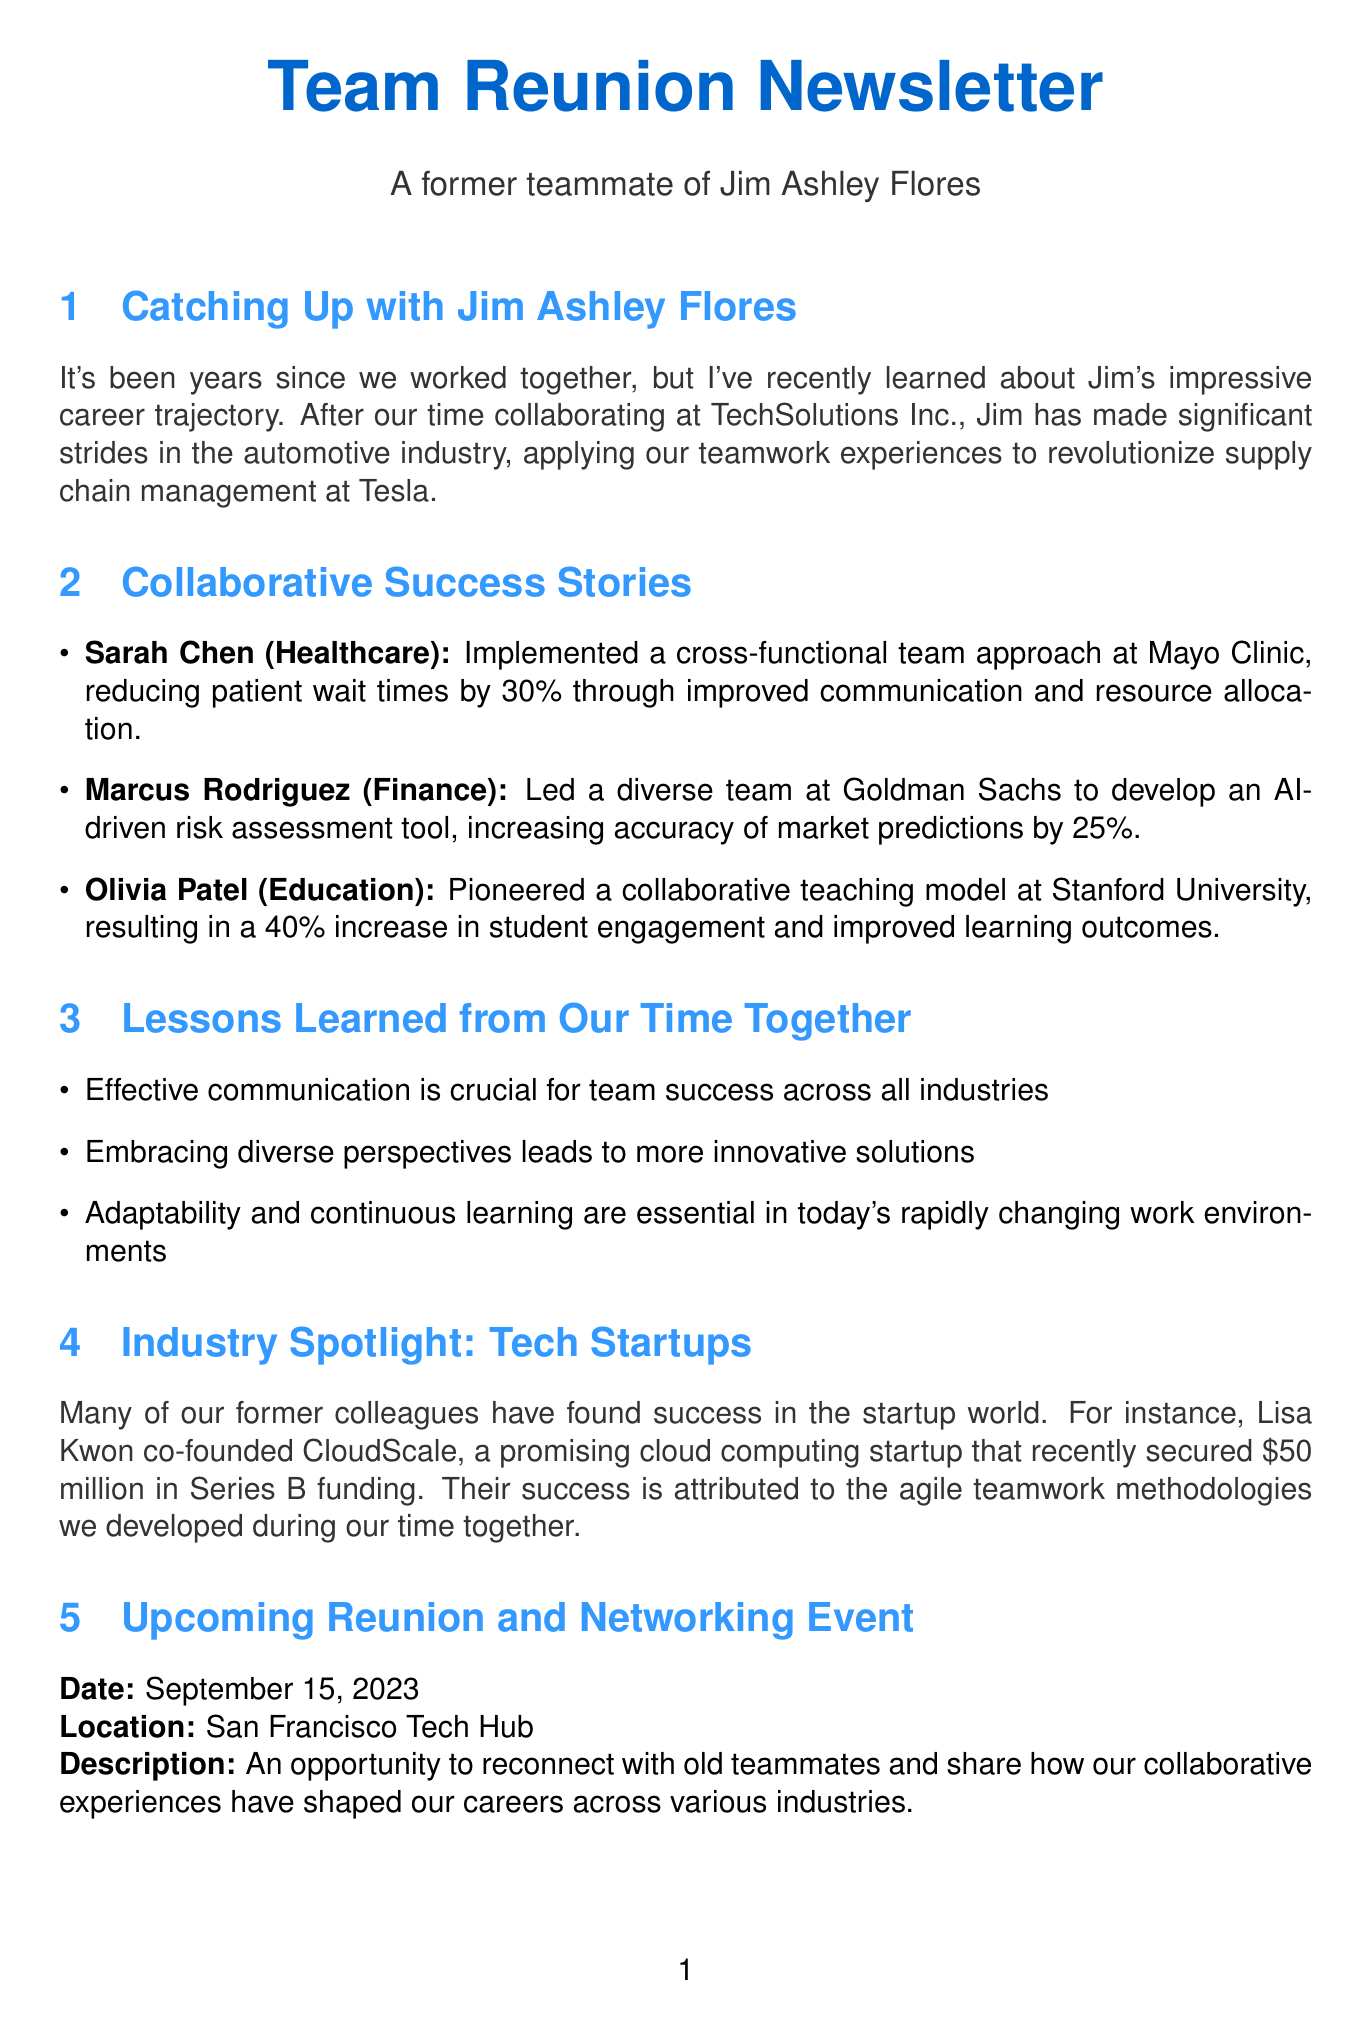What is Jim Ashley Flores's current industry? The document mentions that Jim is currently working in the automotive industry.
Answer: automotive What percentage did Sarah Chen reduce patient wait times by? The document states that Sarah Chen reduced patient wait times by 30 percent.
Answer: 30% Who co-founded CloudScale? The newsletter mentions that Lisa Kwon co-founded CloudScale.
Answer: Lisa Kwon What is the date of the upcoming reunion event? The document provides September 15, 2023 as the date for the upcoming reunion.
Answer: September 15, 2023 What was the achievement of Olivia Patel at Stanford University? The document highlights that Olivia pioneered a collaborative teaching model, leading to a 40 percent increase in student engagement.
Answer: 40% What key point emphasizes the importance of communication? The document lists "Effective communication is crucial for team success across all industries" as a key point.
Answer: Effective communication What company did Marcus Rodriguez work with? The document states that Marcus led a team at Goldman Sachs.
Answer: Goldman Sachs What industry does Olivia Patel's achievement pertain to? The document categorizes Olivia Patel's achievement within the education industry.
Answer: Education What funding amount did CloudScale recently secure? The newsletter mentions that CloudScale recently secured 50 million dollars in Series B funding.
Answer: 50 million 